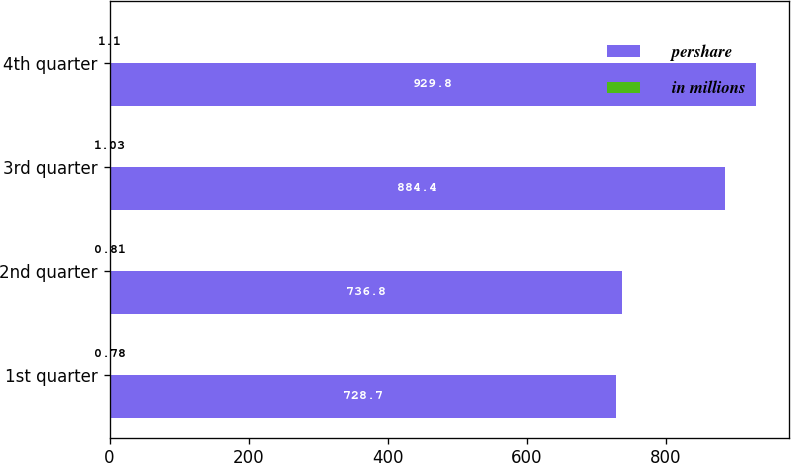Convert chart to OTSL. <chart><loc_0><loc_0><loc_500><loc_500><stacked_bar_chart><ecel><fcel>1st quarter<fcel>2nd quarter<fcel>3rd quarter<fcel>4th quarter<nl><fcel>pershare<fcel>728.7<fcel>736.8<fcel>884.4<fcel>929.8<nl><fcel>in millions<fcel>0.78<fcel>0.81<fcel>1.03<fcel>1.1<nl></chart> 